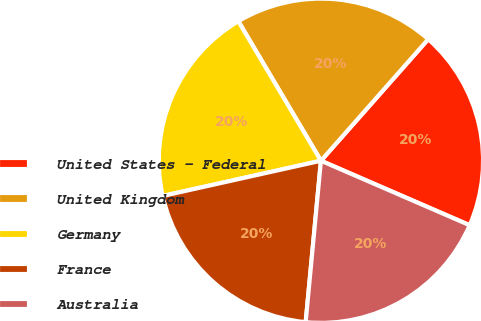<chart> <loc_0><loc_0><loc_500><loc_500><pie_chart><fcel>United States - Federal<fcel>United Kingdom<fcel>Germany<fcel>France<fcel>Australia<nl><fcel>20.0%<fcel>20.02%<fcel>19.98%<fcel>20.01%<fcel>19.99%<nl></chart> 